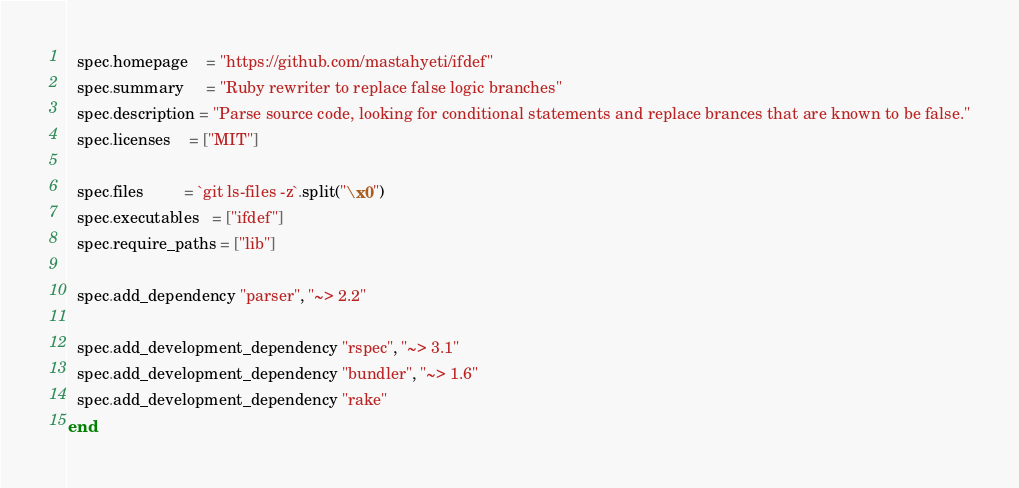Convert code to text. <code><loc_0><loc_0><loc_500><loc_500><_Ruby_>  spec.homepage    = "https://github.com/mastahyeti/ifdef"
  spec.summary     = "Ruby rewriter to replace false logic branches"
  spec.description = "Parse source code, looking for conditional statements and replace brances that are known to be false."
  spec.licenses    = ["MIT"]

  spec.files         = `git ls-files -z`.split("\x0")
  spec.executables   = ["ifdef"]
  spec.require_paths = ["lib"]

  spec.add_dependency "parser", "~> 2.2"

  spec.add_development_dependency "rspec", "~> 3.1"
  spec.add_development_dependency "bundler", "~> 1.6"
  spec.add_development_dependency "rake"
end
</code> 